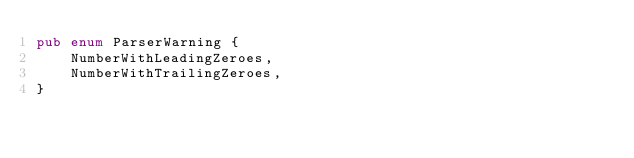<code> <loc_0><loc_0><loc_500><loc_500><_Rust_>pub enum ParserWarning {
    NumberWithLeadingZeroes,
    NumberWithTrailingZeroes,
}
</code> 